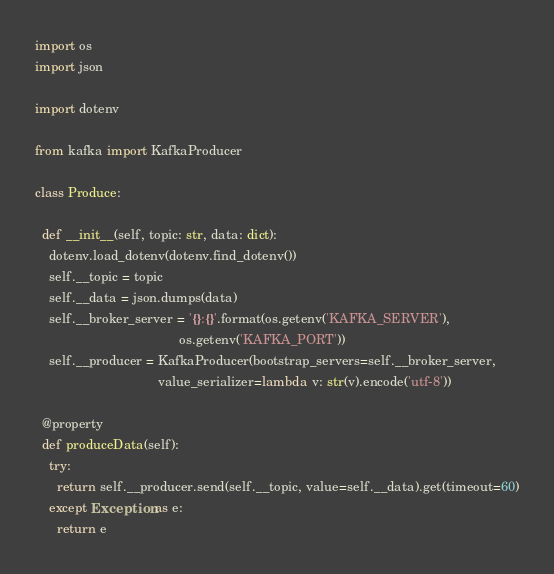Convert code to text. <code><loc_0><loc_0><loc_500><loc_500><_Python_>import os
import json

import dotenv

from kafka import KafkaProducer

class Produce:
  
  def __init__(self, topic: str, data: dict):
    dotenv.load_dotenv(dotenv.find_dotenv())
    self.__topic = topic
    self.__data = json.dumps(data)
    self.__broker_server = '{}:{}'.format(os.getenv('KAFKA_SERVER'),
                                        os.getenv('KAFKA_PORT'))
    self.__producer = KafkaProducer(bootstrap_servers=self.__broker_server, 
                                  value_serializer=lambda v: str(v).encode('utf-8'))
    
  @property
  def produceData(self):
    try:
      return self.__producer.send(self.__topic, value=self.__data).get(timeout=60)
    except Exception as e:
      return e</code> 